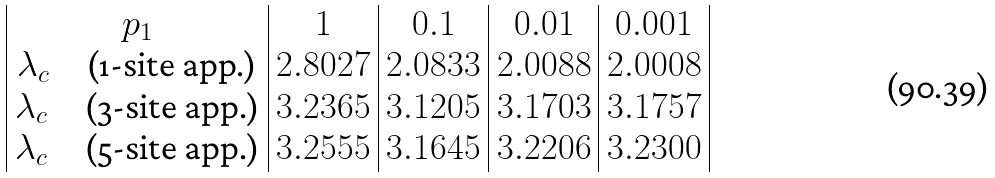Convert formula to latex. <formula><loc_0><loc_0><loc_500><loc_500>\begin{array} { | c | c | c | c | c | } p _ { 1 } & 1 & 0 . 1 & 0 . 0 1 & 0 . 0 0 1 \\ \lambda _ { c } \quad \text {(1-site app.)} & 2 . 8 0 2 7 & 2 . 0 8 3 3 & 2 . 0 0 8 8 & 2 . 0 0 0 8 \\ \lambda _ { c } \quad \text {(3-site app.)} & 3 . 2 3 6 5 & 3 . 1 2 0 5 & 3 . 1 7 0 3 & 3 . 1 7 5 7 \\ \lambda _ { c } \quad \text {(5-site app.)} & 3 . 2 5 5 5 & 3 . 1 6 4 5 & 3 . 2 2 0 6 & 3 . 2 3 0 0 \\ \end{array}</formula> 